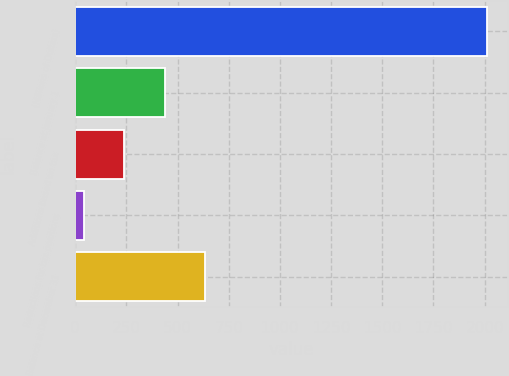Convert chart to OTSL. <chart><loc_0><loc_0><loc_500><loc_500><bar_chart><fcel>(Millions of Dollars)<fcel>Balance at January 1<fcel>Additions based on tax<fcel>Reductions for tax positions<fcel>Balance at December 31<nl><fcel>2011<fcel>436.6<fcel>239.8<fcel>43<fcel>633.4<nl></chart> 